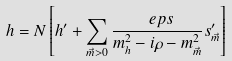<formula> <loc_0><loc_0><loc_500><loc_500>h = N \left [ h ^ { \prime } + \sum _ { \vec { m } > 0 } \frac { \ e p s } { m _ { h } ^ { 2 } - i \rho - m _ { \vec { m } } ^ { 2 } } s _ { \vec { m } } ^ { \prime } \right ]</formula> 